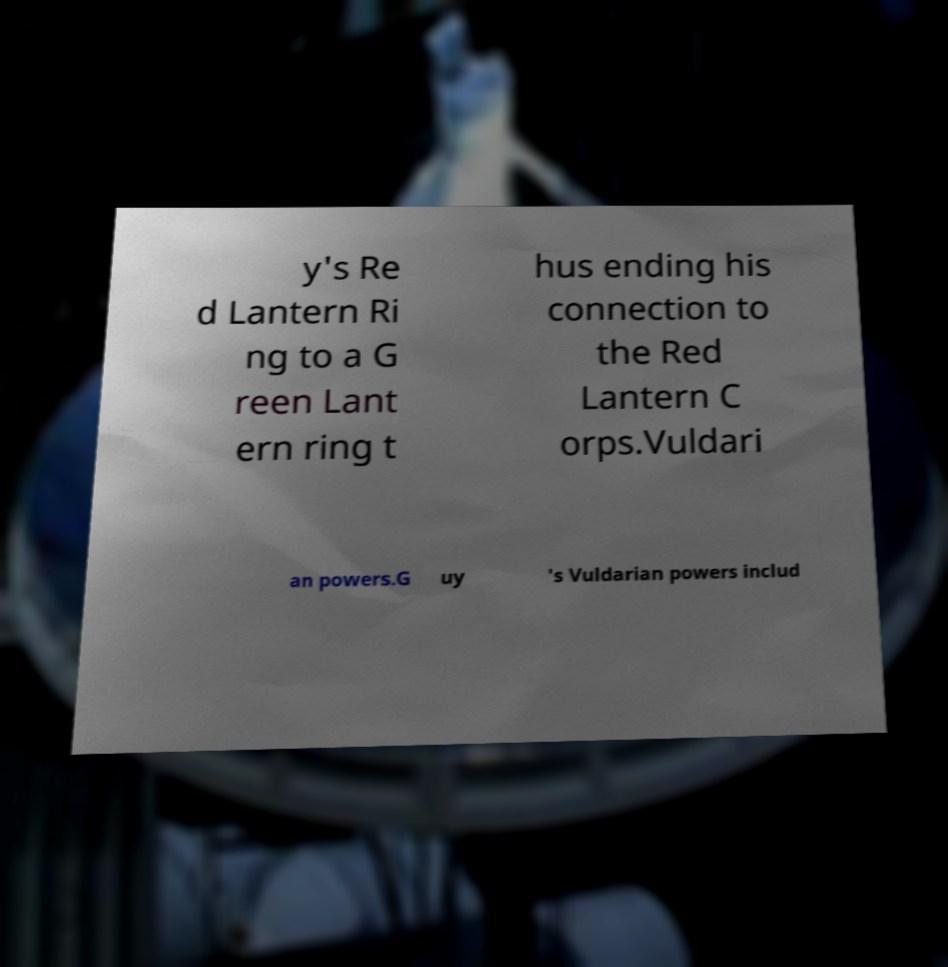There's text embedded in this image that I need extracted. Can you transcribe it verbatim? y's Re d Lantern Ri ng to a G reen Lant ern ring t hus ending his connection to the Red Lantern C orps.Vuldari an powers.G uy 's Vuldarian powers includ 